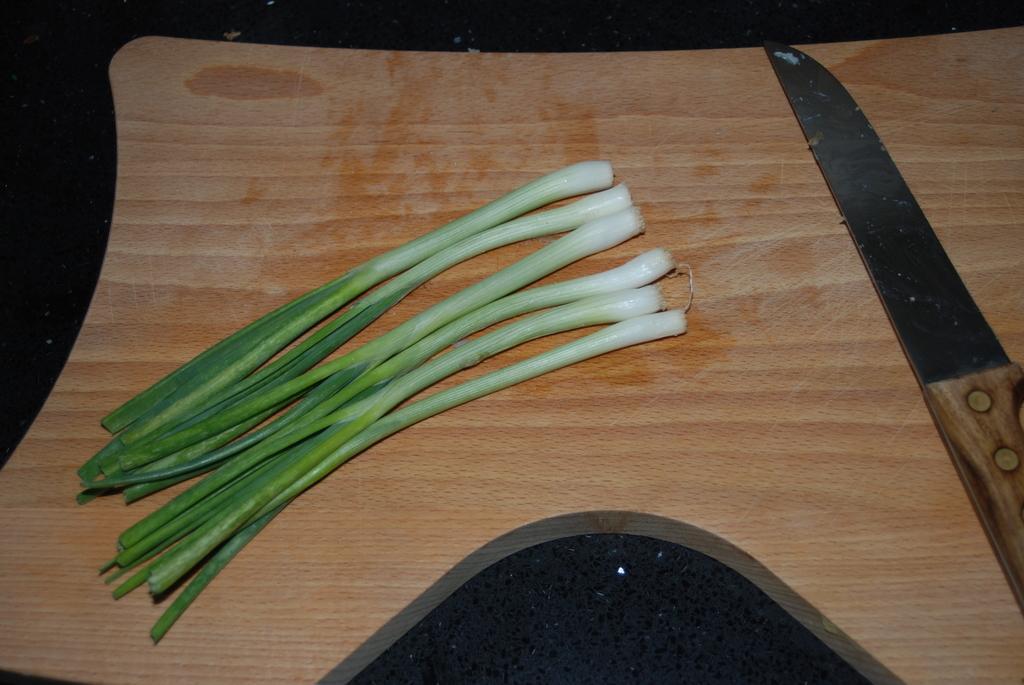Could you give a brief overview of what you see in this image? In this picture we can see a wooden plank, spring onions, knife and these all are placed on a platform. 